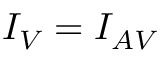Convert formula to latex. <formula><loc_0><loc_0><loc_500><loc_500>I _ { V } = I _ { A V }</formula> 